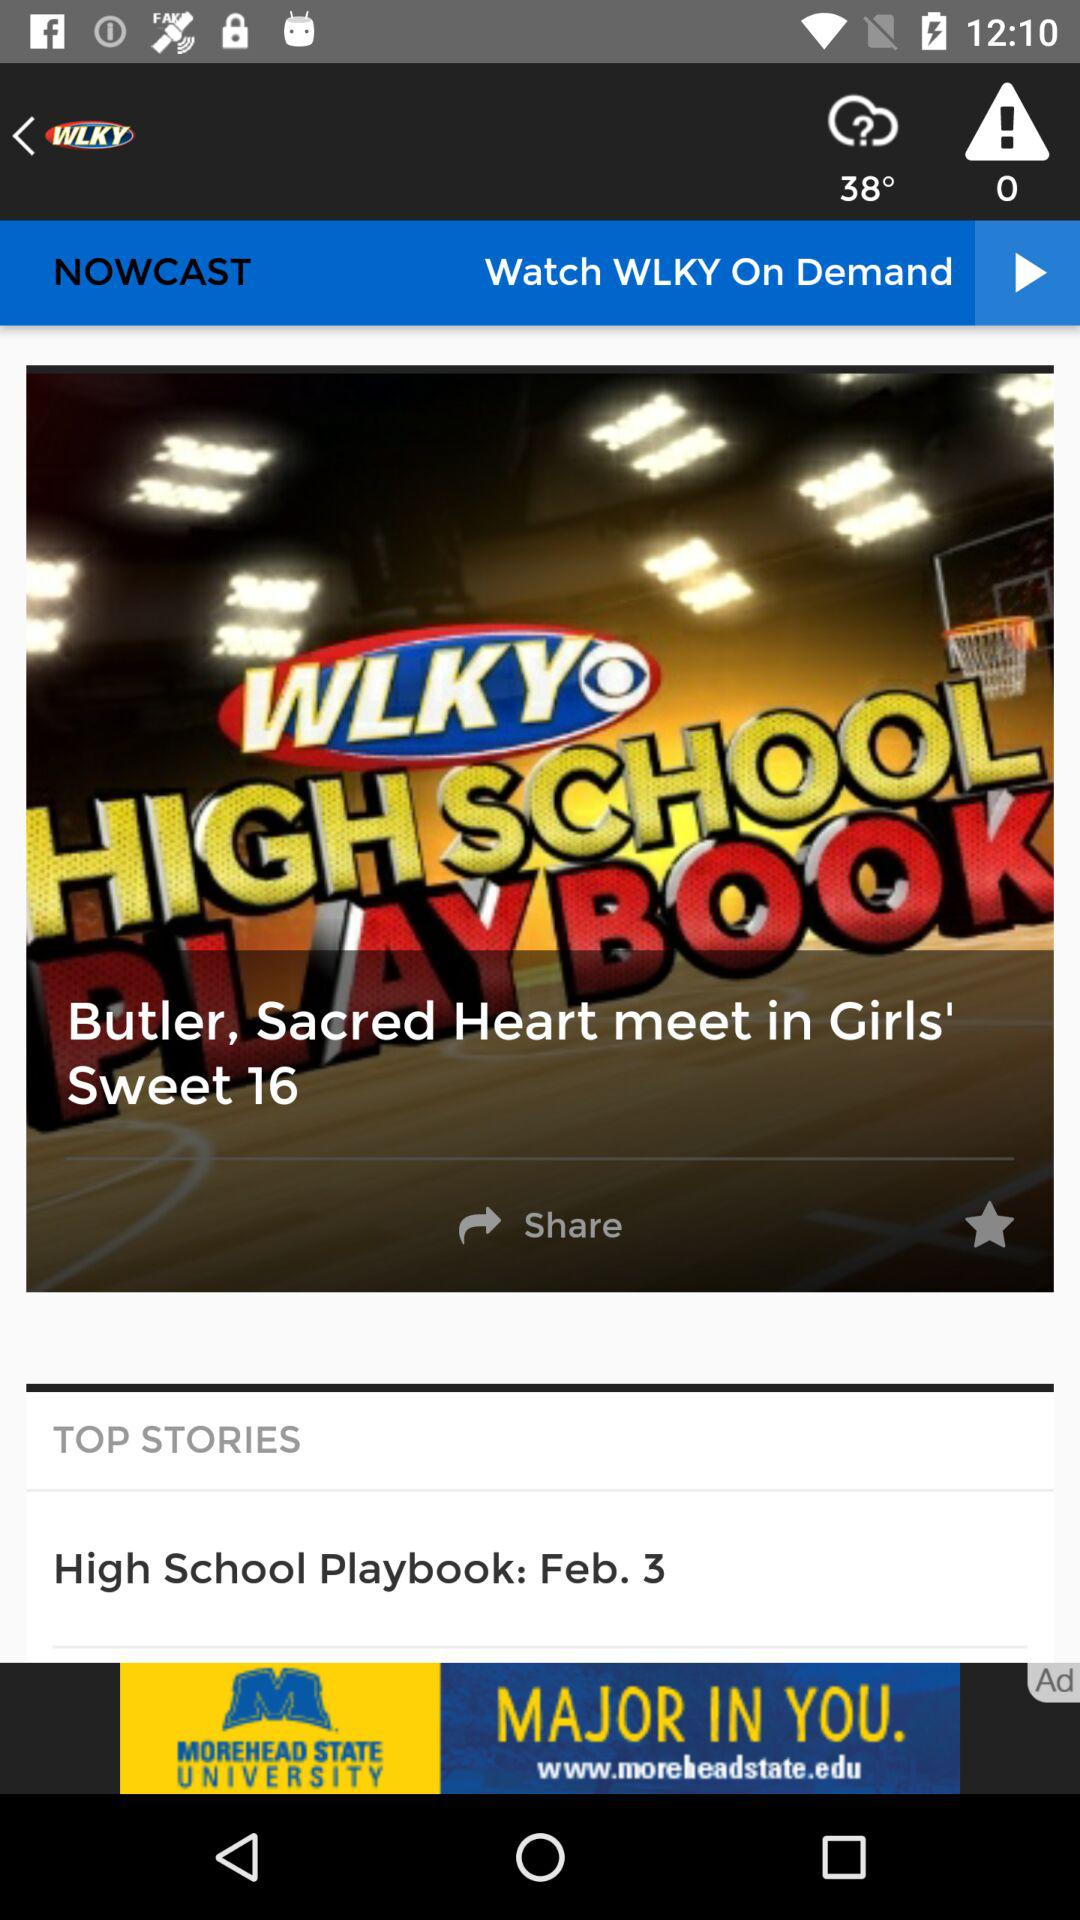Which story is in the "TOP STORIES"? The story that is in the "TOP STORIES" is "High School Playbook: Feb. 3". 